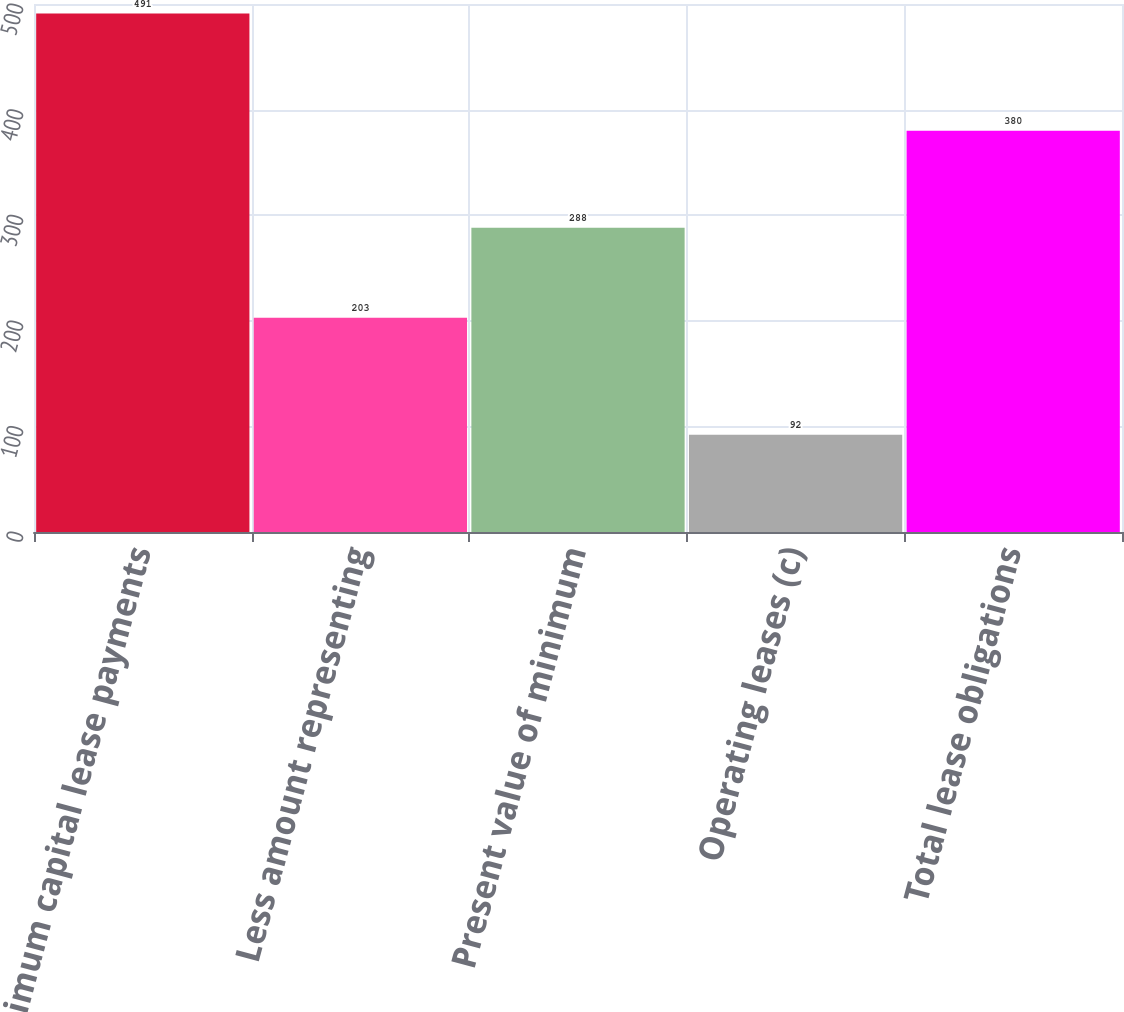Convert chart. <chart><loc_0><loc_0><loc_500><loc_500><bar_chart><fcel>Minimum capital lease payments<fcel>Less amount representing<fcel>Present value of minimum<fcel>Operating leases (c)<fcel>Total lease obligations<nl><fcel>491<fcel>203<fcel>288<fcel>92<fcel>380<nl></chart> 